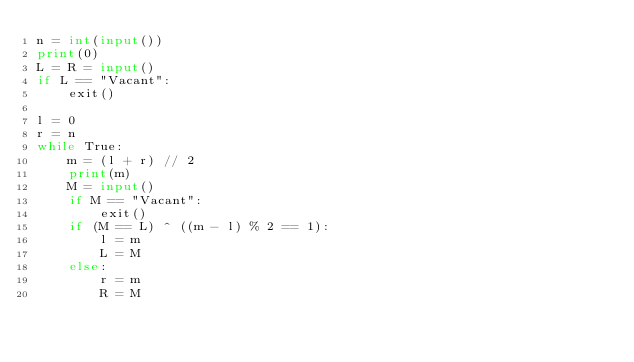<code> <loc_0><loc_0><loc_500><loc_500><_Python_>n = int(input())
print(0)
L = R = input()
if L == "Vacant":
    exit()

l = 0
r = n
while True:
    m = (l + r) // 2
    print(m)
    M = input()
    if M == "Vacant":
        exit()
    if (M == L) ^ ((m - l) % 2 == 1):
        l = m
        L = M
    else:
        r = m
        R = M

</code> 